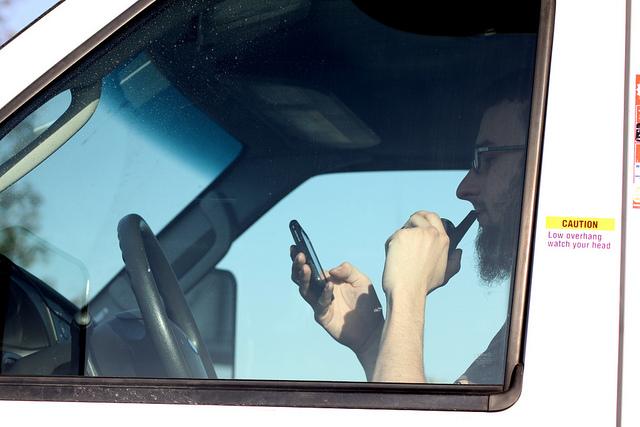Is this person smoking?
Write a very short answer. Yes. What is in the truck?
Be succinct. Man. Is the driver a man or a woman?
Quick response, please. Man. What is the person holding in his right hand?
Write a very short answer. Phone. 